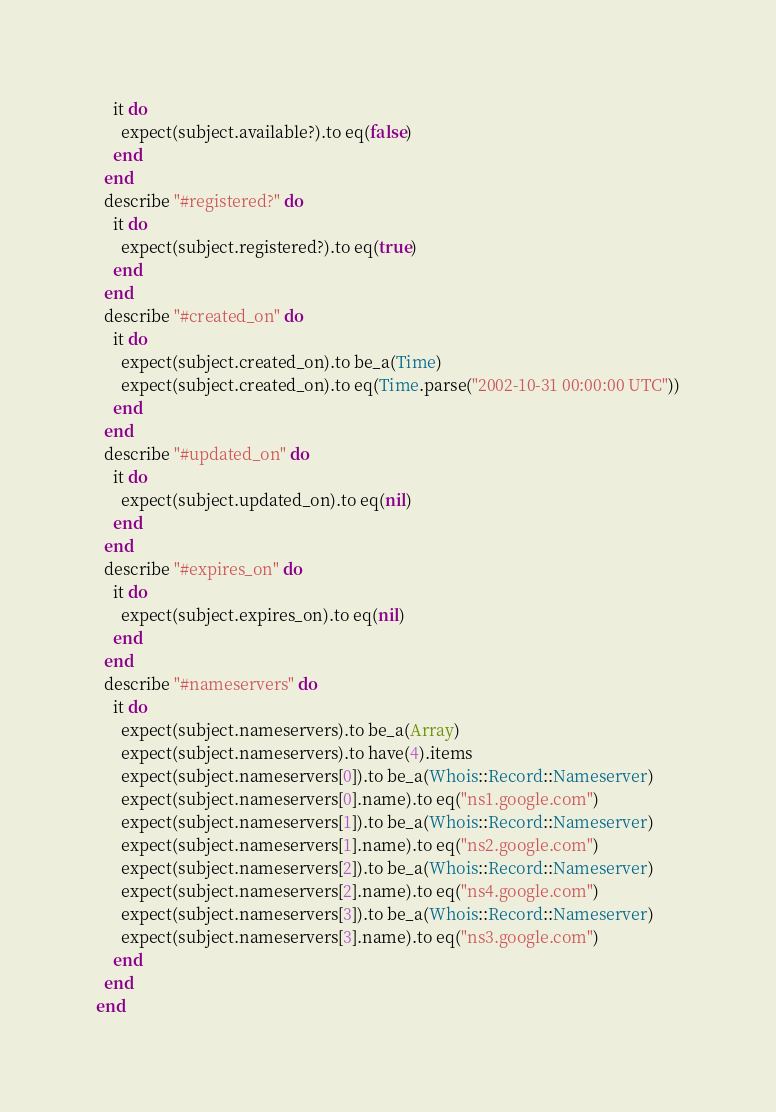<code> <loc_0><loc_0><loc_500><loc_500><_Ruby_>    it do
      expect(subject.available?).to eq(false)
    end
  end
  describe "#registered?" do
    it do
      expect(subject.registered?).to eq(true)
    end
  end
  describe "#created_on" do
    it do
      expect(subject.created_on).to be_a(Time)
      expect(subject.created_on).to eq(Time.parse("2002-10-31 00:00:00 UTC"))
    end
  end
  describe "#updated_on" do
    it do
      expect(subject.updated_on).to eq(nil)
    end
  end
  describe "#expires_on" do
    it do
      expect(subject.expires_on).to eq(nil)
    end
  end
  describe "#nameservers" do
    it do
      expect(subject.nameservers).to be_a(Array)
      expect(subject.nameservers).to have(4).items
      expect(subject.nameservers[0]).to be_a(Whois::Record::Nameserver)
      expect(subject.nameservers[0].name).to eq("ns1.google.com")
      expect(subject.nameservers[1]).to be_a(Whois::Record::Nameserver)
      expect(subject.nameservers[1].name).to eq("ns2.google.com")
      expect(subject.nameservers[2]).to be_a(Whois::Record::Nameserver)
      expect(subject.nameservers[2].name).to eq("ns4.google.com")
      expect(subject.nameservers[3]).to be_a(Whois::Record::Nameserver)
      expect(subject.nameservers[3].name).to eq("ns3.google.com")
    end
  end
end
</code> 